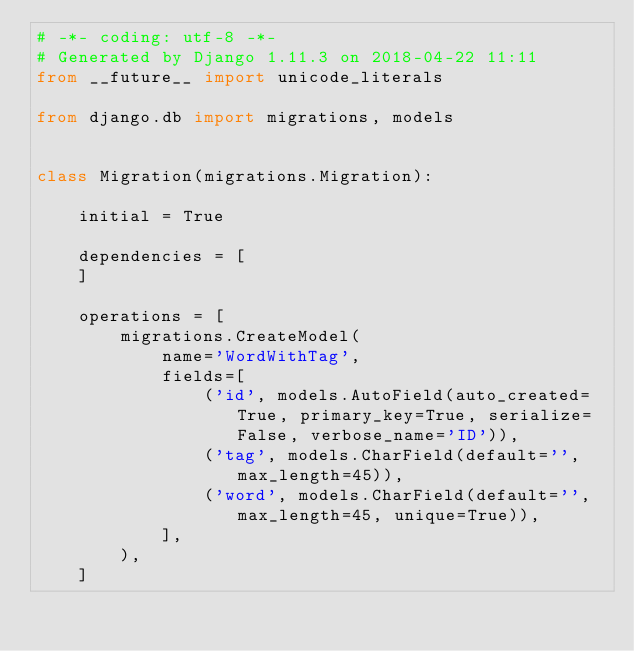<code> <loc_0><loc_0><loc_500><loc_500><_Python_># -*- coding: utf-8 -*-
# Generated by Django 1.11.3 on 2018-04-22 11:11
from __future__ import unicode_literals

from django.db import migrations, models


class Migration(migrations.Migration):

    initial = True

    dependencies = [
    ]

    operations = [
        migrations.CreateModel(
            name='WordWithTag',
            fields=[
                ('id', models.AutoField(auto_created=True, primary_key=True, serialize=False, verbose_name='ID')),
                ('tag', models.CharField(default='', max_length=45)),
                ('word', models.CharField(default='', max_length=45, unique=True)),
            ],
        ),
    ]
</code> 